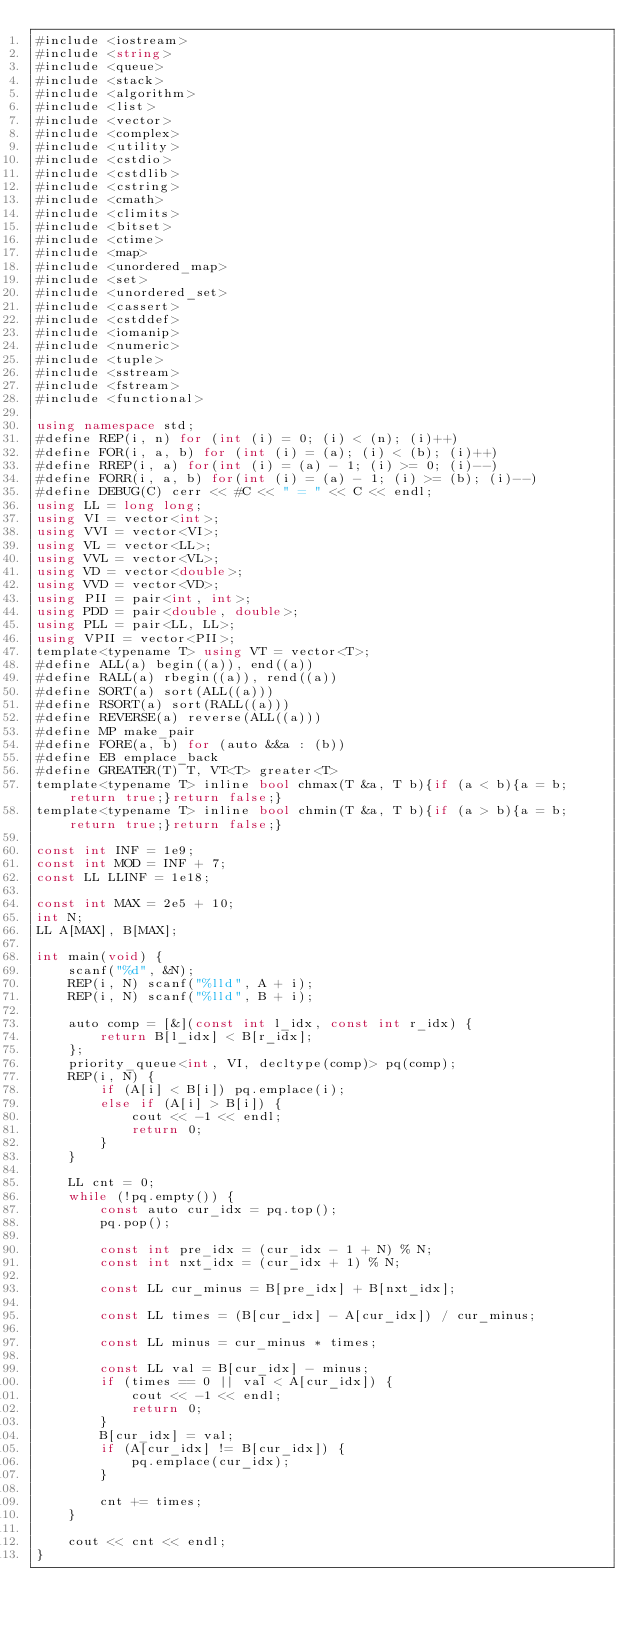<code> <loc_0><loc_0><loc_500><loc_500><_C#_>#include <iostream>
#include <string>
#include <queue>
#include <stack>
#include <algorithm>
#include <list>
#include <vector>
#include <complex>
#include <utility>
#include <cstdio>
#include <cstdlib>
#include <cstring>
#include <cmath>
#include <climits>
#include <bitset>
#include <ctime>
#include <map>
#include <unordered_map>
#include <set>
#include <unordered_set>
#include <cassert>
#include <cstddef>
#include <iomanip>
#include <numeric>
#include <tuple>
#include <sstream>
#include <fstream>
#include <functional>

using namespace std;
#define REP(i, n) for (int (i) = 0; (i) < (n); (i)++)
#define FOR(i, a, b) for (int (i) = (a); (i) < (b); (i)++)
#define RREP(i, a) for(int (i) = (a) - 1; (i) >= 0; (i)--)
#define FORR(i, a, b) for(int (i) = (a) - 1; (i) >= (b); (i)--)
#define DEBUG(C) cerr << #C << " = " << C << endl;
using LL = long long;
using VI = vector<int>;
using VVI = vector<VI>;
using VL = vector<LL>;
using VVL = vector<VL>;
using VD = vector<double>;
using VVD = vector<VD>;
using PII = pair<int, int>;
using PDD = pair<double, double>;
using PLL = pair<LL, LL>;
using VPII = vector<PII>;
template<typename T> using VT = vector<T>;
#define ALL(a) begin((a)), end((a))
#define RALL(a) rbegin((a)), rend((a))
#define SORT(a) sort(ALL((a)))
#define RSORT(a) sort(RALL((a)))
#define REVERSE(a) reverse(ALL((a)))
#define MP make_pair
#define FORE(a, b) for (auto &&a : (b))
#define EB emplace_back
#define GREATER(T) T, VT<T> greater<T>
template<typename T> inline bool chmax(T &a, T b){if (a < b){a = b;return true;}return false;}
template<typename T> inline bool chmin(T &a, T b){if (a > b){a = b;return true;}return false;}

const int INF = 1e9;
const int MOD = INF + 7;
const LL LLINF = 1e18;

const int MAX = 2e5 + 10;
int N;
LL A[MAX], B[MAX];

int main(void) {
    scanf("%d", &N);
    REP(i, N) scanf("%lld", A + i);
    REP(i, N) scanf("%lld", B + i);

    auto comp = [&](const int l_idx, const int r_idx) {
        return B[l_idx] < B[r_idx];
    };
    priority_queue<int, VI, decltype(comp)> pq(comp);
    REP(i, N) {
        if (A[i] < B[i]) pq.emplace(i);
        else if (A[i] > B[i]) {
            cout << -1 << endl;
            return 0;
        }
    }

    LL cnt = 0;
    while (!pq.empty()) {
        const auto cur_idx = pq.top();
        pq.pop();

        const int pre_idx = (cur_idx - 1 + N) % N;
        const int nxt_idx = (cur_idx + 1) % N;

        const LL cur_minus = B[pre_idx] + B[nxt_idx];

        const LL times = (B[cur_idx] - A[cur_idx]) / cur_minus;

        const LL minus = cur_minus * times;

        const LL val = B[cur_idx] - minus;
        if (times == 0 || val < A[cur_idx]) {
            cout << -1 << endl;
            return 0;
        }
        B[cur_idx] = val;
        if (A[cur_idx] != B[cur_idx]) {
            pq.emplace(cur_idx);
        }

        cnt += times;
    }

    cout << cnt << endl;
}
</code> 